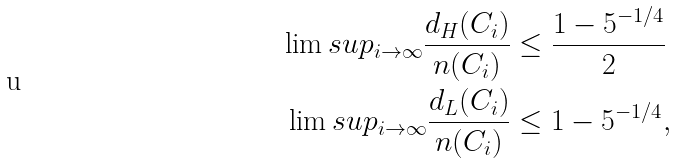<formula> <loc_0><loc_0><loc_500><loc_500>\lim s u p _ { i \to \infty } \frac { d _ { H } ( C _ { i } ) } { n ( C _ { i } ) } & \leq \frac { 1 - 5 ^ { - 1 / 4 } } { 2 } \\ \lim s u p _ { i \to \infty } \frac { d _ { L } ( C _ { i } ) } { n ( C _ { i } ) } & \leq 1 - 5 ^ { - 1 / 4 } ,</formula> 